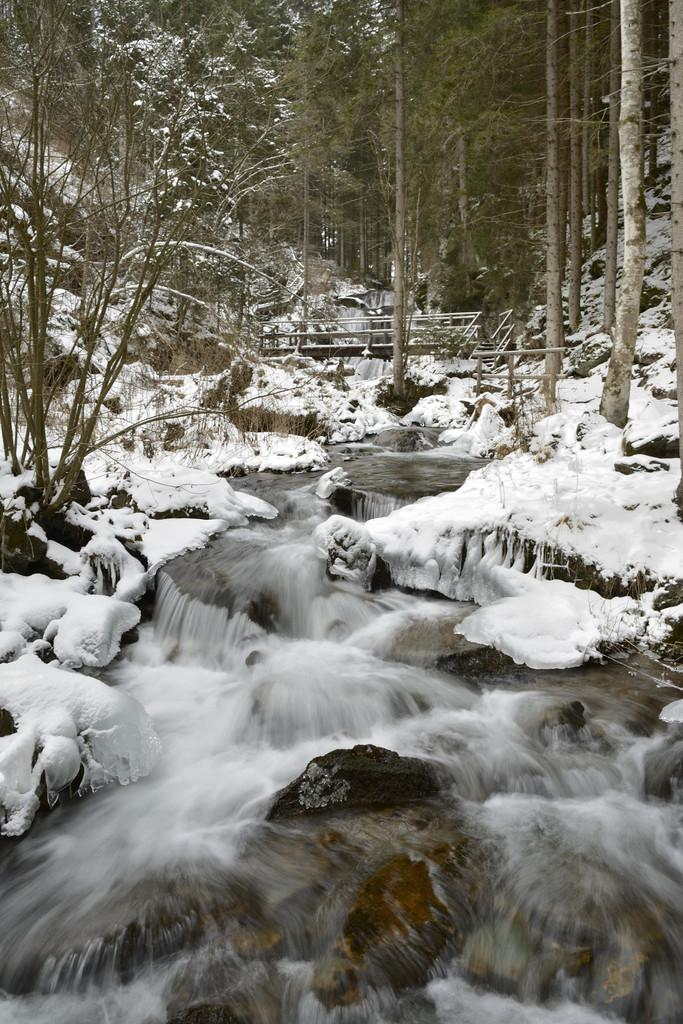What type of natural environment is depicted in the image? The image features trees, a mountain, and water at the bottom, indicating a natural environment. Can you describe the mountain in the image? There is a mountain in the image. What is present at the bottom of the image? There is water at the bottom of the image. Is there any snow visible in the image? Yes, there is snow in the image. What structure can be seen in the background of the image? There appears to be a bridge in the background of the image. What type of soap is being used to clean the lake in the image? There is no lake or soap present in the image. What is the shocking event happening in the image? There is no shocking event depicted in the image; it features a natural landscape with trees, a mountain, water, snow, and a bridge. 